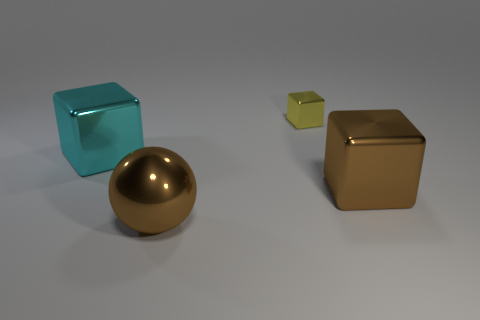Which object appears to be closest to the viewpoint? The large brown metallic cube on the right appears to be the closest object to the viewpoint, based on its size and positioning in the image. Is there any object that appears behind the golden ball? Yes, the small greenish-yellow cube appears to be located directly behind the golden ball. 